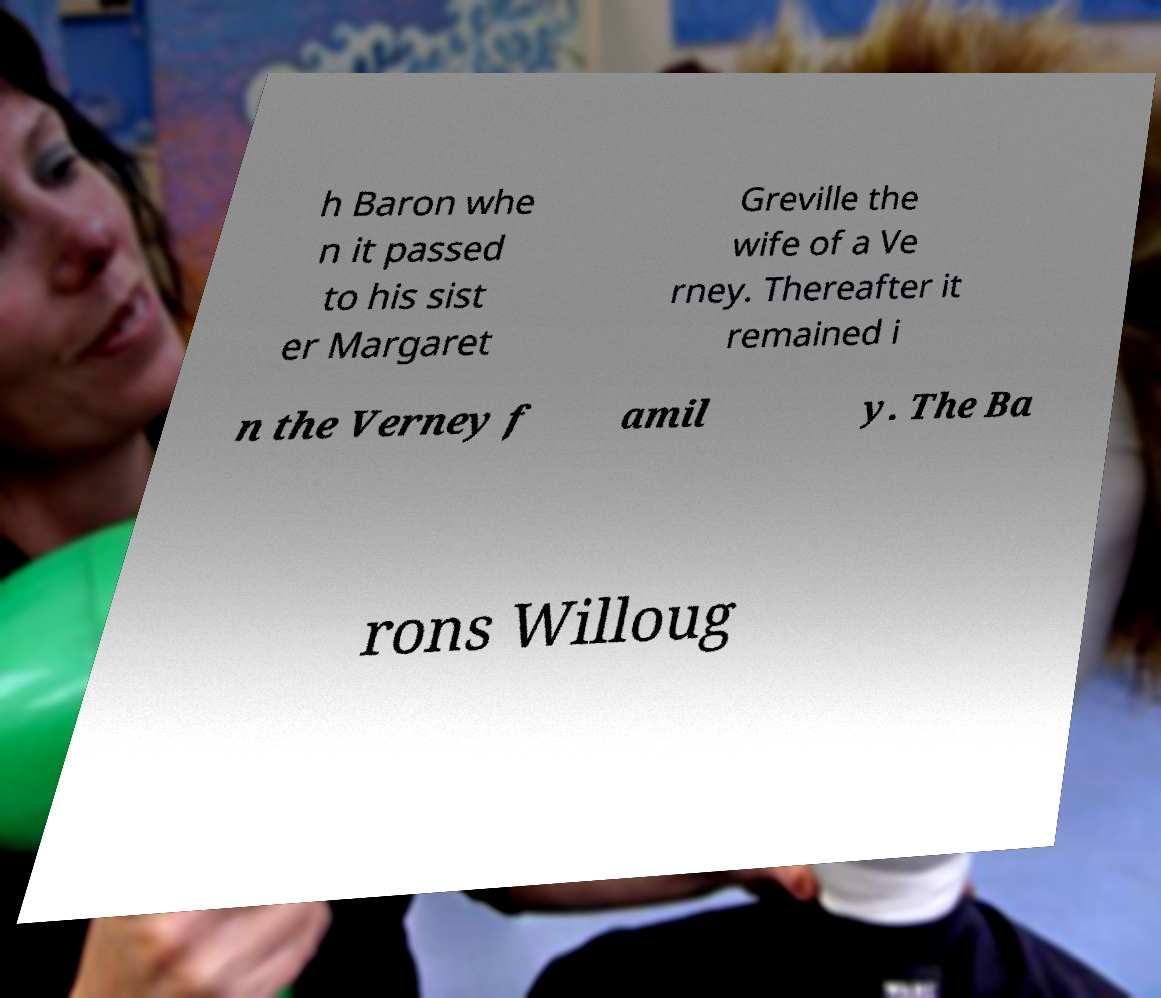Can you accurately transcribe the text from the provided image for me? h Baron whe n it passed to his sist er Margaret Greville the wife of a Ve rney. Thereafter it remained i n the Verney f amil y. The Ba rons Willoug 